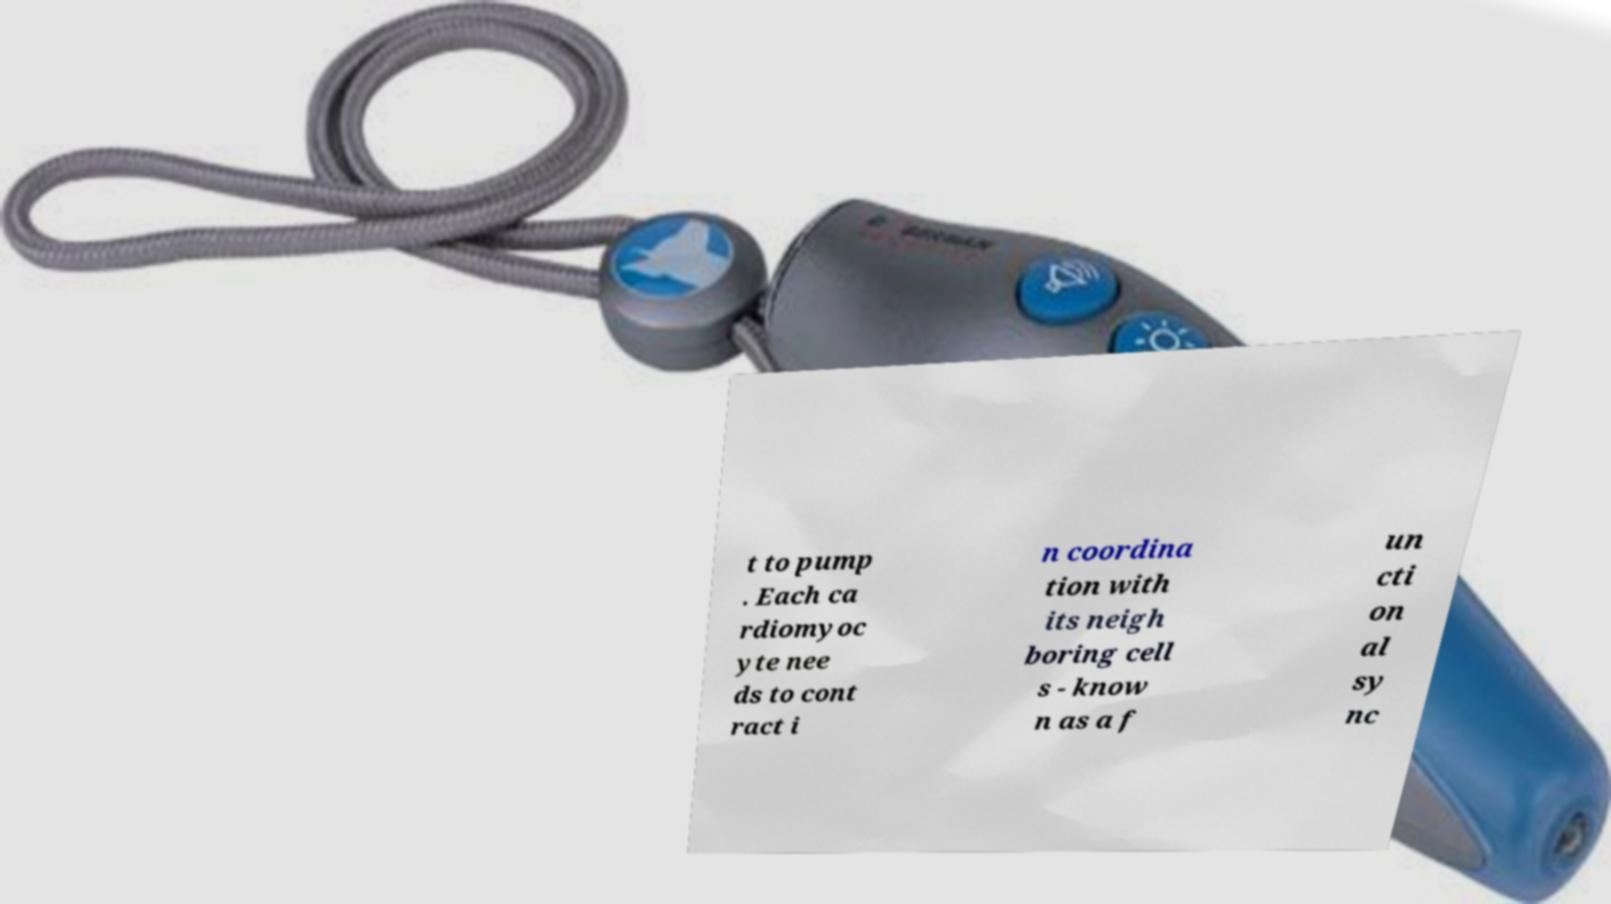I need the written content from this picture converted into text. Can you do that? t to pump . Each ca rdiomyoc yte nee ds to cont ract i n coordina tion with its neigh boring cell s - know n as a f un cti on al sy nc 